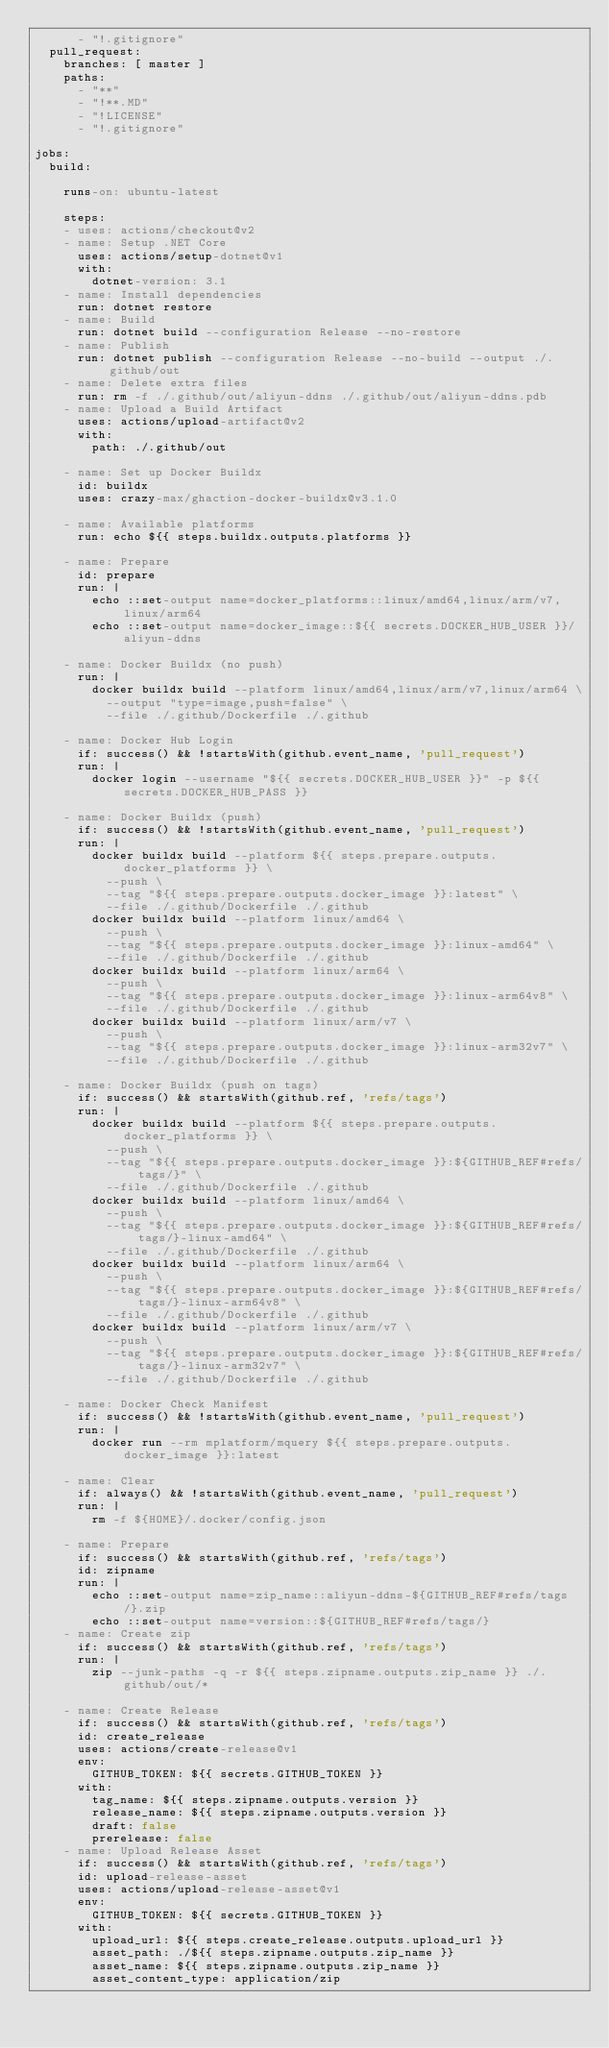Convert code to text. <code><loc_0><loc_0><loc_500><loc_500><_YAML_>      - "!.gitignore"
  pull_request:
    branches: [ master ]
    paths:
      - "**"
      - "!**.MD"
      - "!LICENSE"
      - "!.gitignore"

jobs:
  build:

    runs-on: ubuntu-latest

    steps:
    - uses: actions/checkout@v2
    - name: Setup .NET Core
      uses: actions/setup-dotnet@v1
      with:
        dotnet-version: 3.1
    - name: Install dependencies
      run: dotnet restore
    - name: Build
      run: dotnet build --configuration Release --no-restore
    - name: Publish
      run: dotnet publish --configuration Release --no-build --output ./.github/out
    - name: Delete extra files
      run: rm -f ./.github/out/aliyun-ddns ./.github/out/aliyun-ddns.pdb
    - name: Upload a Build Artifact
      uses: actions/upload-artifact@v2
      with:
        path: ./.github/out
    
    - name: Set up Docker Buildx
      id: buildx
      uses: crazy-max/ghaction-docker-buildx@v3.1.0
    
    - name: Available platforms
      run: echo ${{ steps.buildx.outputs.platforms }}
      
    - name: Prepare
      id: prepare
      run: |
        echo ::set-output name=docker_platforms::linux/amd64,linux/arm/v7,linux/arm64
        echo ::set-output name=docker_image::${{ secrets.DOCKER_HUB_USER }}/aliyun-ddns
        
    - name: Docker Buildx (no push)
      run: |
        docker buildx build --platform linux/amd64,linux/arm/v7,linux/arm64 \
          --output "type=image,push=false" \
          --file ./.github/Dockerfile ./.github
           
    - name: Docker Hub Login
      if: success() && !startsWith(github.event_name, 'pull_request')
      run: |
        docker login --username "${{ secrets.DOCKER_HUB_USER }}" -p ${{ secrets.DOCKER_HUB_PASS }}
        
    - name: Docker Buildx (push)
      if: success() && !startsWith(github.event_name, 'pull_request')
      run: |
        docker buildx build --platform ${{ steps.prepare.outputs.docker_platforms }} \
          --push \
          --tag "${{ steps.prepare.outputs.docker_image }}:latest" \
          --file ./.github/Dockerfile ./.github
        docker buildx build --platform linux/amd64 \
          --push \
          --tag "${{ steps.prepare.outputs.docker_image }}:linux-amd64" \
          --file ./.github/Dockerfile ./.github
        docker buildx build --platform linux/arm64 \
          --push \
          --tag "${{ steps.prepare.outputs.docker_image }}:linux-arm64v8" \
          --file ./.github/Dockerfile ./.github
        docker buildx build --platform linux/arm/v7 \
          --push \
          --tag "${{ steps.prepare.outputs.docker_image }}:linux-arm32v7" \
          --file ./.github/Dockerfile ./.github
        
    - name: Docker Buildx (push on tags)
      if: success() && startsWith(github.ref, 'refs/tags')
      run: |
        docker buildx build --platform ${{ steps.prepare.outputs.docker_platforms }} \
          --push \
          --tag "${{ steps.prepare.outputs.docker_image }}:${GITHUB_REF#refs/tags/}" \
          --file ./.github/Dockerfile ./.github
        docker buildx build --platform linux/amd64 \
          --push \
          --tag "${{ steps.prepare.outputs.docker_image }}:${GITHUB_REF#refs/tags/}-linux-amd64" \
          --file ./.github/Dockerfile ./.github
        docker buildx build --platform linux/arm64 \
          --push \
          --tag "${{ steps.prepare.outputs.docker_image }}:${GITHUB_REF#refs/tags/}-linux-arm64v8" \
          --file ./.github/Dockerfile ./.github
        docker buildx build --platform linux/arm/v7 \
          --push \
          --tag "${{ steps.prepare.outputs.docker_image }}:${GITHUB_REF#refs/tags/}-linux-arm32v7" \
          --file ./.github/Dockerfile ./.github

    - name: Docker Check Manifest
      if: success() && !startsWith(github.event_name, 'pull_request')
      run: |
        docker run --rm mplatform/mquery ${{ steps.prepare.outputs.docker_image }}:latest

    - name: Clear
      if: always() && !startsWith(github.event_name, 'pull_request')
      run: |
        rm -f ${HOME}/.docker/config.json
        
    - name: Prepare
      if: success() && startsWith(github.ref, 'refs/tags')
      id: zipname
      run: |
        echo ::set-output name=zip_name::aliyun-ddns-${GITHUB_REF#refs/tags/}.zip
        echo ::set-output name=version::${GITHUB_REF#refs/tags/}
    - name: Create zip
      if: success() && startsWith(github.ref, 'refs/tags')
      run: |
        zip --junk-paths -q -r ${{ steps.zipname.outputs.zip_name }} ./.github/out/*
          
    - name: Create Release
      if: success() && startsWith(github.ref, 'refs/tags')
      id: create_release
      uses: actions/create-release@v1
      env:
        GITHUB_TOKEN: ${{ secrets.GITHUB_TOKEN }}
      with:
        tag_name: ${{ steps.zipname.outputs.version }}
        release_name: ${{ steps.zipname.outputs.version }}
        draft: false
        prerelease: false
    - name: Upload Release Asset
      if: success() && startsWith(github.ref, 'refs/tags')
      id: upload-release-asset 
      uses: actions/upload-release-asset@v1
      env:
        GITHUB_TOKEN: ${{ secrets.GITHUB_TOKEN }}
      with:
        upload_url: ${{ steps.create_release.outputs.upload_url }} 
        asset_path: ./${{ steps.zipname.outputs.zip_name }}
        asset_name: ${{ steps.zipname.outputs.zip_name }}
        asset_content_type: application/zip
</code> 